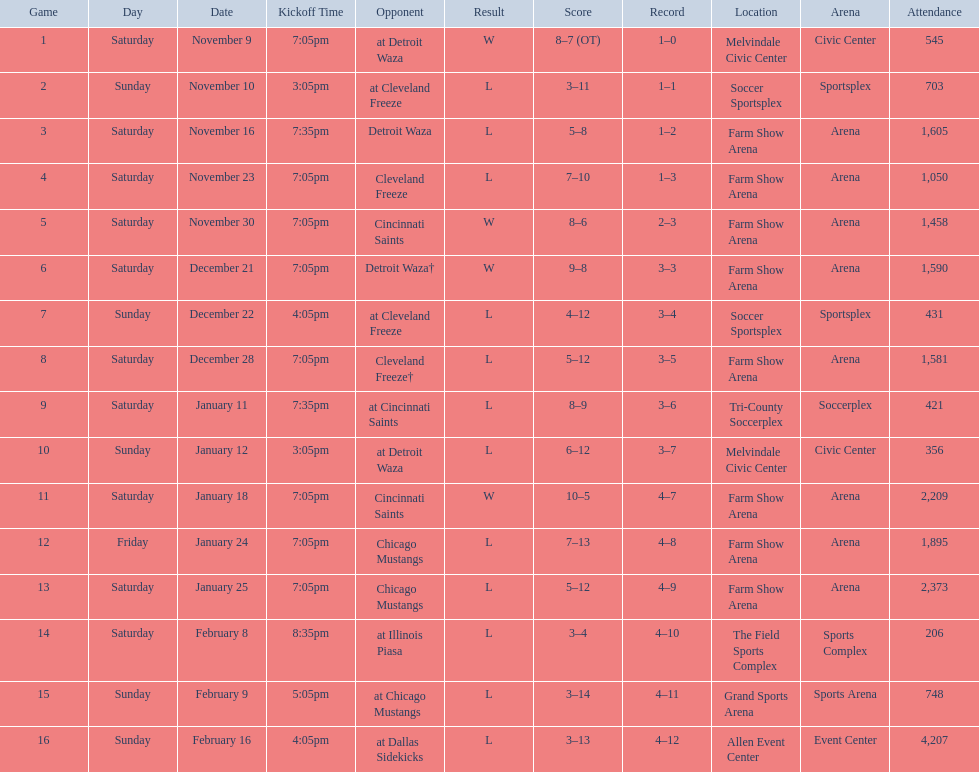Which opponent is listed after cleveland freeze in the table? Detroit Waza. 